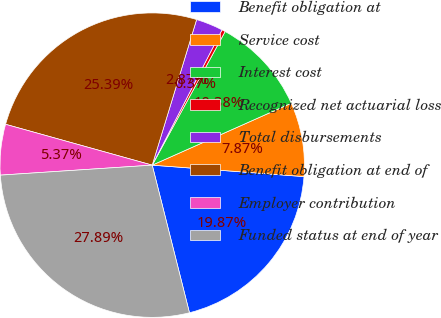Convert chart to OTSL. <chart><loc_0><loc_0><loc_500><loc_500><pie_chart><fcel>Benefit obligation at<fcel>Service cost<fcel>Interest cost<fcel>Recognized net actuarial loss<fcel>Total disbursements<fcel>Benefit obligation at end of<fcel>Employer contribution<fcel>Funded status at end of year<nl><fcel>19.87%<fcel>7.87%<fcel>10.38%<fcel>0.37%<fcel>2.87%<fcel>25.39%<fcel>5.37%<fcel>27.89%<nl></chart> 